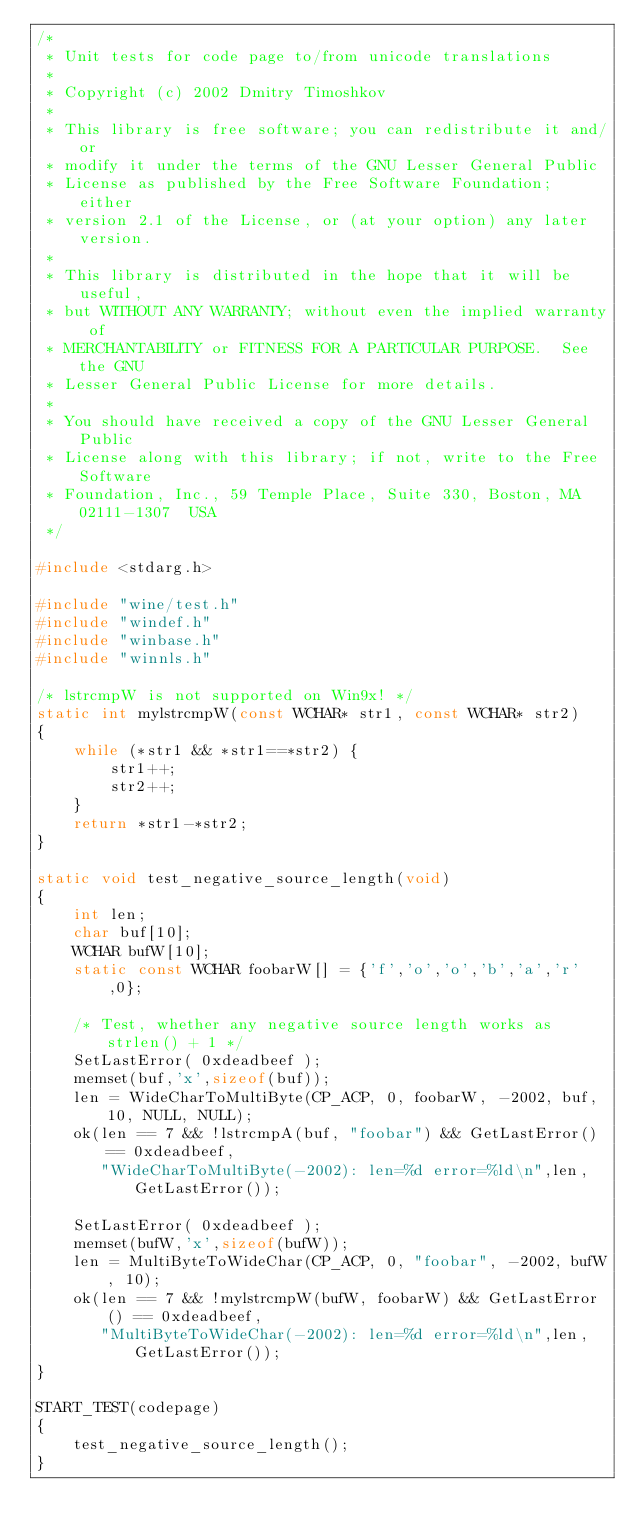Convert code to text. <code><loc_0><loc_0><loc_500><loc_500><_C_>/*
 * Unit tests for code page to/from unicode translations
 *
 * Copyright (c) 2002 Dmitry Timoshkov
 *
 * This library is free software; you can redistribute it and/or
 * modify it under the terms of the GNU Lesser General Public
 * License as published by the Free Software Foundation; either
 * version 2.1 of the License, or (at your option) any later version.
 *
 * This library is distributed in the hope that it will be useful,
 * but WITHOUT ANY WARRANTY; without even the implied warranty of
 * MERCHANTABILITY or FITNESS FOR A PARTICULAR PURPOSE.  See the GNU
 * Lesser General Public License for more details.
 *
 * You should have received a copy of the GNU Lesser General Public
 * License along with this library; if not, write to the Free Software
 * Foundation, Inc., 59 Temple Place, Suite 330, Boston, MA  02111-1307  USA
 */

#include <stdarg.h>

#include "wine/test.h"
#include "windef.h"
#include "winbase.h"
#include "winnls.h"

/* lstrcmpW is not supported on Win9x! */
static int mylstrcmpW(const WCHAR* str1, const WCHAR* str2)
{
    while (*str1 && *str1==*str2) {
        str1++;
        str2++;
    }
    return *str1-*str2;
}

static void test_negative_source_length(void)
{
    int len;
    char buf[10];
    WCHAR bufW[10];
    static const WCHAR foobarW[] = {'f','o','o','b','a','r',0};

    /* Test, whether any negative source length works as strlen() + 1 */
    SetLastError( 0xdeadbeef );
    memset(buf,'x',sizeof(buf));
    len = WideCharToMultiByte(CP_ACP, 0, foobarW, -2002, buf, 10, NULL, NULL);
    ok(len == 7 && !lstrcmpA(buf, "foobar") && GetLastError() == 0xdeadbeef,
       "WideCharToMultiByte(-2002): len=%d error=%ld\n",len,GetLastError());

    SetLastError( 0xdeadbeef );
    memset(bufW,'x',sizeof(bufW));
    len = MultiByteToWideChar(CP_ACP, 0, "foobar", -2002, bufW, 10);
    ok(len == 7 && !mylstrcmpW(bufW, foobarW) && GetLastError() == 0xdeadbeef,
       "MultiByteToWideChar(-2002): len=%d error=%ld\n",len,GetLastError());
}

START_TEST(codepage)
{
    test_negative_source_length();
}
</code> 